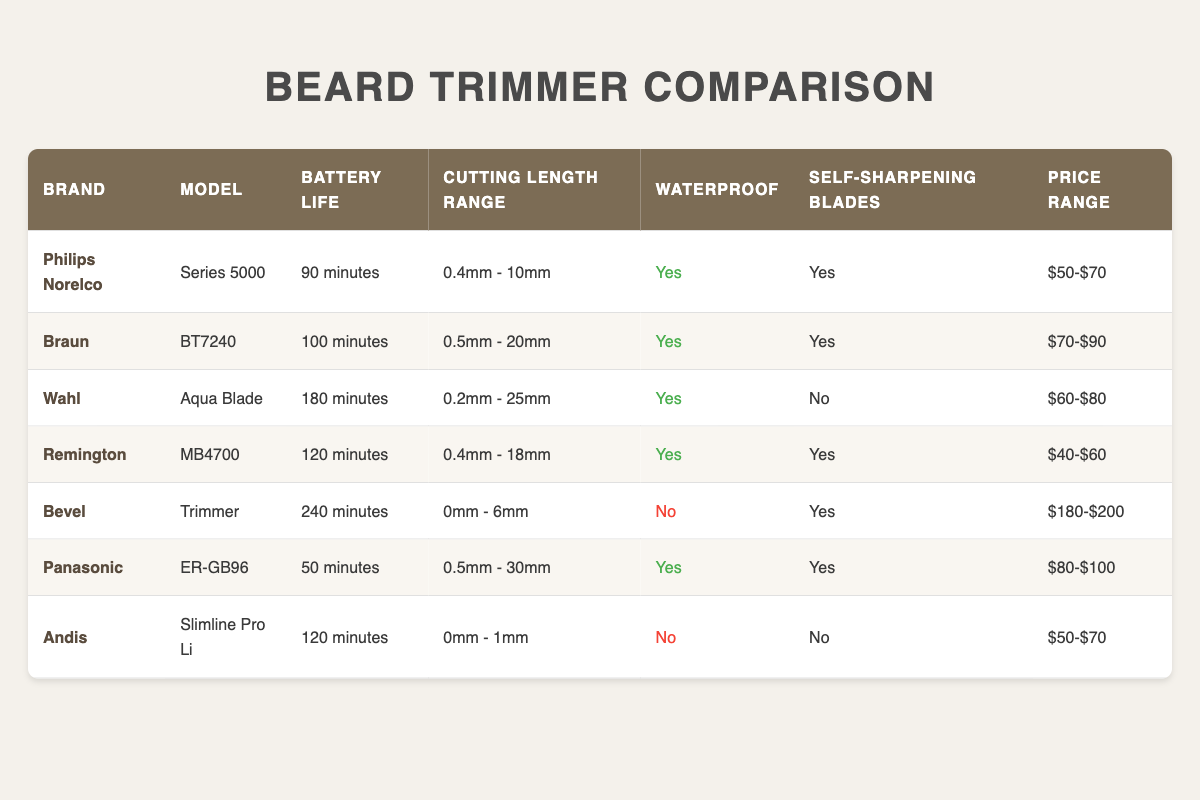What is the battery life of the Braun BT7240 trimmer? The table shows that the battery life of the Braun BT7240 model is listed as 100 minutes.
Answer: 100 minutes Which trimmer has the longest battery life? By comparing the battery life across all models, the Bevel Trimmer has the longest battery life of 240 minutes.
Answer: Bevel Trimmer Is the Wahl Aqua Blade waterproof? The table indicates that the Wahl Aqua Blade has a "Yes" under the Waterproof column, confirming it is waterproof.
Answer: Yes What is the cutting length range of the Panasonic ER-GB96? According to the table, the cutting length range for the Panasonic ER-GB96 is 0.5mm - 30mm.
Answer: 0.5mm - 30mm How many trimmers listed have self-sharpening blades? The table indicates that four trimmers (Philips Norelco Series 5000, Braun BT7240, Remington MB4700, and Bevel Trimmer) have self-sharpening blades.
Answer: Four What is the price range of the trimmer with the shortest battery life? The Panasonic ER-GB96 has the shortest battery life of 50 minutes, and its price range is $80-$100.
Answer: $80-$100 Which brand offers the widest cutting length range? By examining the Cutting Length Range column, the Wahl Aqua Blade offers the widest range at 0.2mm - 25mm.
Answer: Wahl Aqua Blade How much more expensive is the Bevel Trimmer compared to the Remington MB4700? The price range for the Bevel Trimmer is $180-$200, while the Remington MB4700 is $40-$60. Taking the highest price of the Bevel Trimmer ($200) and subtracting the lowest price of the Remington ($40), the difference is $200 - $40 = $160.
Answer: $160 Are all trimmers from brands that have waterproof features priced similarly? By comparing the prices of trimmers that are waterproof, the ranges vary: Philips Norelco is $50-$70, Braun is $70-$90, Wahl is $60-$80, Remington is $40-$60, and Panasonic is $80-$100. Thus, the prices are not similar across the waterproof options.
Answer: No 